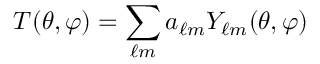Convert formula to latex. <formula><loc_0><loc_0><loc_500><loc_500>T ( \theta , \varphi ) = \sum _ { \ell m } a _ { \ell m } Y _ { \ell m } ( \theta , \varphi )</formula> 